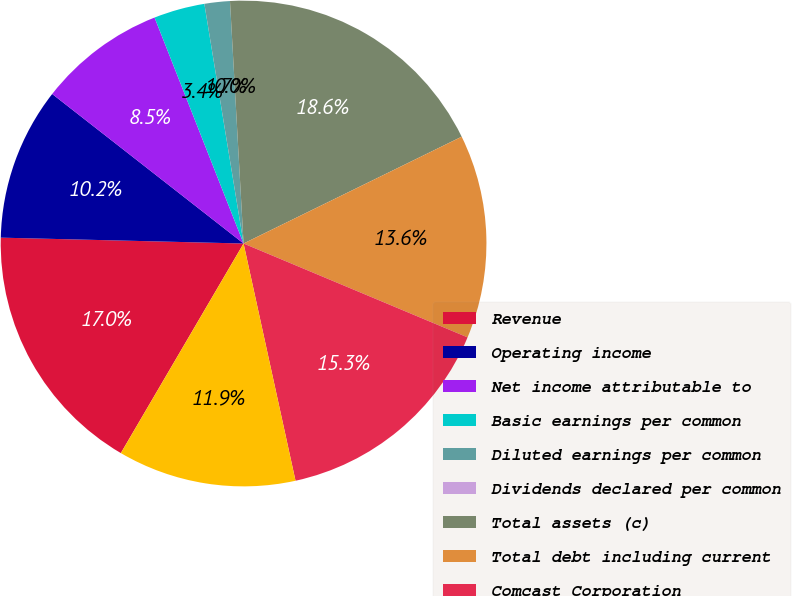Convert chart to OTSL. <chart><loc_0><loc_0><loc_500><loc_500><pie_chart><fcel>Revenue<fcel>Operating income<fcel>Net income attributable to<fcel>Basic earnings per common<fcel>Diluted earnings per common<fcel>Dividends declared per common<fcel>Total assets (c)<fcel>Total debt including current<fcel>Comcast Corporation<fcel>Operating activities<nl><fcel>16.95%<fcel>10.17%<fcel>8.47%<fcel>3.39%<fcel>1.69%<fcel>0.0%<fcel>18.64%<fcel>13.56%<fcel>15.25%<fcel>11.86%<nl></chart> 